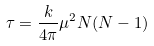Convert formula to latex. <formula><loc_0><loc_0><loc_500><loc_500>\tau = \frac { k } { 4 \pi } \mu ^ { 2 } N ( N - 1 )</formula> 